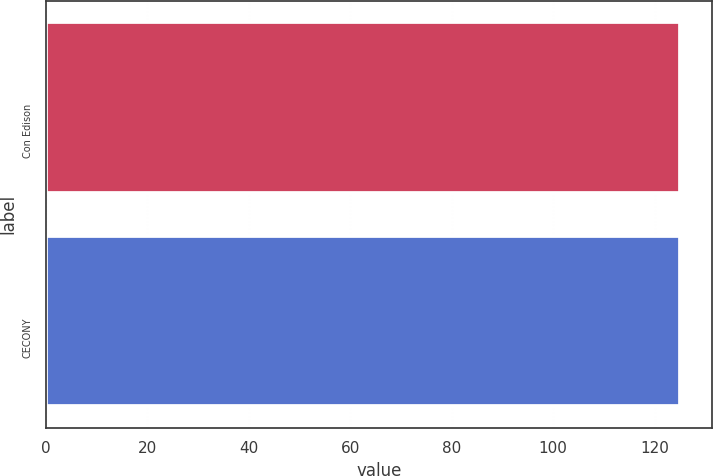Convert chart to OTSL. <chart><loc_0><loc_0><loc_500><loc_500><bar_chart><fcel>Con Edison<fcel>CECONY<nl><fcel>125<fcel>125.1<nl></chart> 